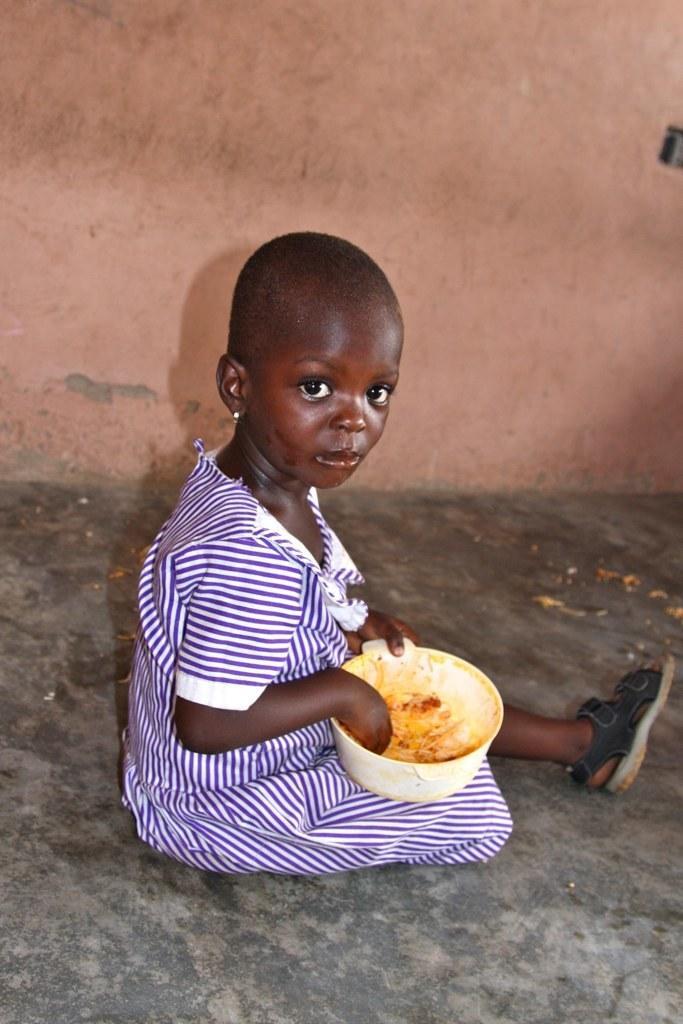Describe this image in one or two sentences. In the image there is a girl sitting on the floor and eating food. Behind the girl there is a wall. 